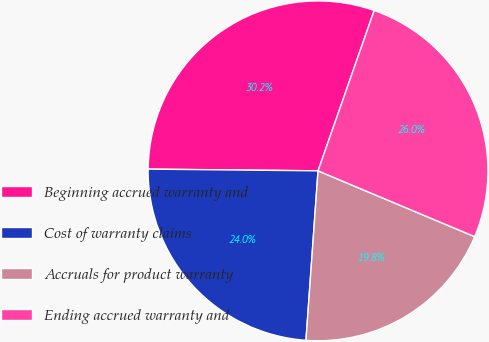Convert chart. <chart><loc_0><loc_0><loc_500><loc_500><pie_chart><fcel>Beginning accrued warranty and<fcel>Cost of warranty claims<fcel>Accruals for product warranty<fcel>Ending accrued warranty and<nl><fcel>30.2%<fcel>24.03%<fcel>19.8%<fcel>25.97%<nl></chart> 